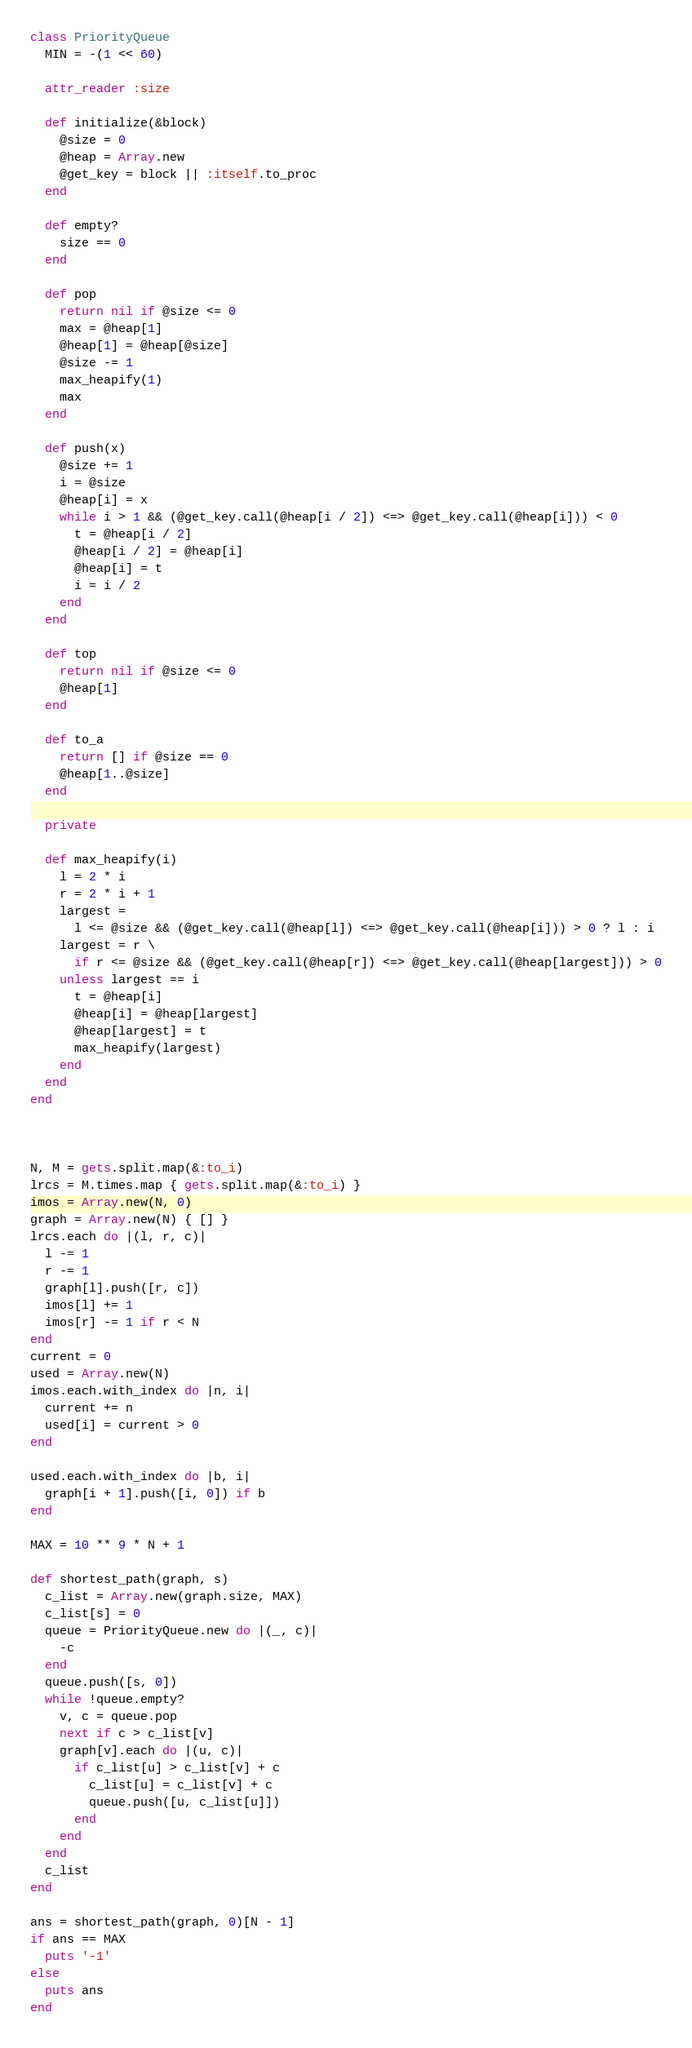<code> <loc_0><loc_0><loc_500><loc_500><_Ruby_>class PriorityQueue
  MIN = -(1 << 60)

  attr_reader :size

  def initialize(&block)
    @size = 0
    @heap = Array.new
    @get_key = block || :itself.to_proc
  end

  def empty?
    size == 0
  end

  def pop
    return nil if @size <= 0
    max = @heap[1]
    @heap[1] = @heap[@size]
    @size -= 1
    max_heapify(1)
    max
  end

  def push(x)
    @size += 1
    i = @size
    @heap[i] = x
    while i > 1 && (@get_key.call(@heap[i / 2]) <=> @get_key.call(@heap[i])) < 0
      t = @heap[i / 2]
      @heap[i / 2] = @heap[i]
      @heap[i] = t
      i = i / 2
    end
  end

  def top
    return nil if @size <= 0
    @heap[1]
  end

  def to_a
    return [] if @size == 0
    @heap[1..@size]
  end

  private

  def max_heapify(i)
    l = 2 * i
    r = 2 * i + 1
    largest =
      l <= @size && (@get_key.call(@heap[l]) <=> @get_key.call(@heap[i])) > 0 ? l : i
    largest = r \
      if r <= @size && (@get_key.call(@heap[r]) <=> @get_key.call(@heap[largest])) > 0
    unless largest == i
      t = @heap[i]
      @heap[i] = @heap[largest]
      @heap[largest] = t
      max_heapify(largest)
    end
  end
end



N, M = gets.split.map(&:to_i)
lrcs = M.times.map { gets.split.map(&:to_i) }
imos = Array.new(N, 0)
graph = Array.new(N) { [] }
lrcs.each do |(l, r, c)|
  l -= 1
  r -= 1
  graph[l].push([r, c])
  imos[l] += 1
  imos[r] -= 1 if r < N
end
current = 0
used = Array.new(N)
imos.each.with_index do |n, i|
  current += n
  used[i] = current > 0
end

used.each.with_index do |b, i|
  graph[i + 1].push([i, 0]) if b
end

MAX = 10 ** 9 * N + 1

def shortest_path(graph, s)
  c_list = Array.new(graph.size, MAX)
  c_list[s] = 0
  queue = PriorityQueue.new do |(_, c)|
    -c
  end
  queue.push([s, 0])
  while !queue.empty?
    v, c = queue.pop
    next if c > c_list[v]
    graph[v].each do |(u, c)|
      if c_list[u] > c_list[v] + c
        c_list[u] = c_list[v] + c
        queue.push([u, c_list[u]])
      end
    end
  end
  c_list
end

ans = shortest_path(graph, 0)[N - 1]
if ans == MAX
  puts '-1'
else
  puts ans
end
</code> 